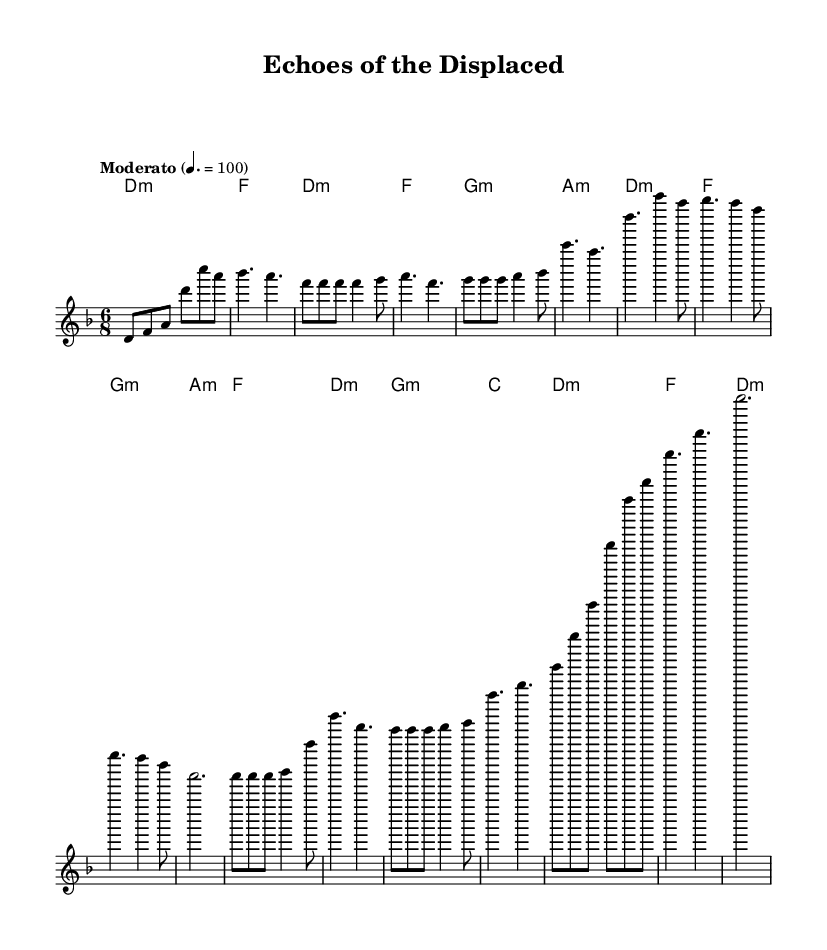What is the key signature of this music? The key signature is D minor, which has one flat (B flat) indicated at the beginning of the staff.
Answer: D minor What is the time signature of this music? The time signature is indicated as 6/8, which shows that there are six eighth notes in each measure.
Answer: 6/8 What is the tempo marking for this piece? The tempo marking reads "Moderato," and it specifies a speed of 100 beats per minute.
Answer: Moderato How many sections are in the song based on the structure visible? The song has five distinct sections: Intro, Verse, Chorus, Bridge, and Outro, indicated by the arrangement of the melody and harmonies.
Answer: Five What type of chord progression is used in the verse? The chord progression for the verse alternates between D minor, F major, G minor, and A minor, reflecting typical folk influences in its harmonic structure.
Answer: D minor, F major, G minor, A minor In the chorus, what is the highest note played? The highest note in the chorus melody is D, which is found in the first measure of the chorus section.
Answer: D Does this piece express themes related to colonization? Yes, the title "Echoes of the Displaced" suggests a thematic focus on personal stories related to the experiences of individuals affected by colonization.
Answer: Yes 